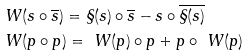Convert formula to latex. <formula><loc_0><loc_0><loc_500><loc_500>& \ W ( s \circ \overline { s } ) = \S ( s ) \circ \overline { s } - s \circ \overline { \S ( s ) } \\ & \ W ( p \circ p ) = \ W ( p ) \circ p + p \circ \ W ( p )</formula> 